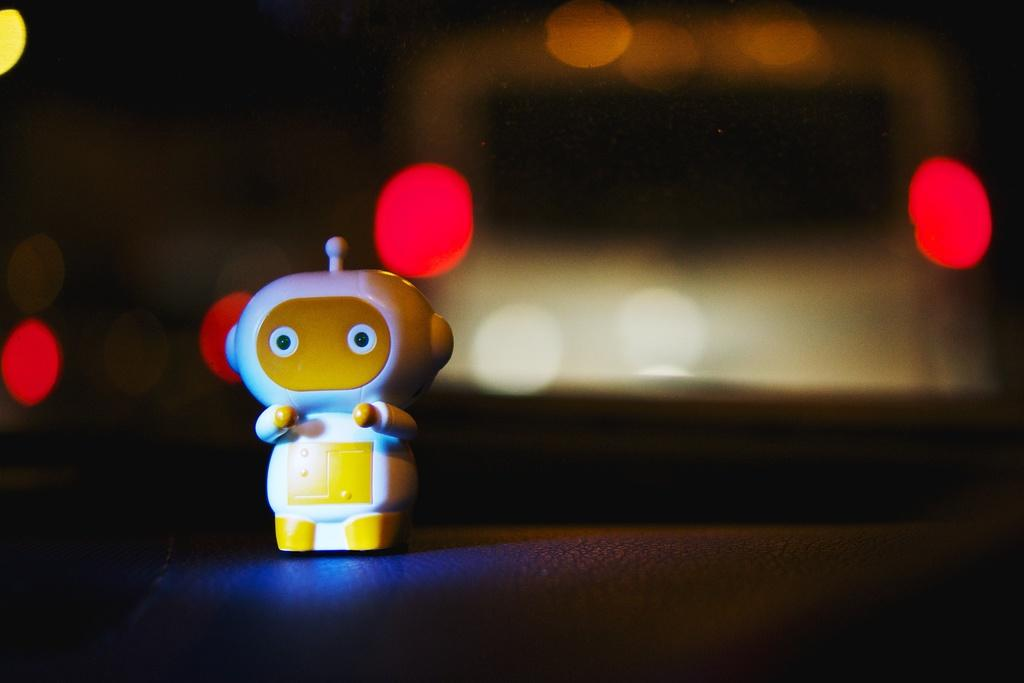What object can be seen in the image? There is a toy in the image. What colors are present on the toy? The toy is white and yellow in color. How is the toy positioned in the image? The toy is blurred in the background. What else can be seen in the image besides the toy? Red lights are visible in the image. What type of flag is being waved at the event in the image? There is no flag or event present in the image; it only features a toy and red lights. What kind of linen is draped over the furniture in the image? There is no furniture or linen present in the image; it only features a toy and red lights. 